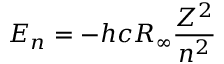<formula> <loc_0><loc_0><loc_500><loc_500>E _ { n } = - h c R _ { \infty } { \frac { Z ^ { 2 } } { n ^ { 2 } } }</formula> 